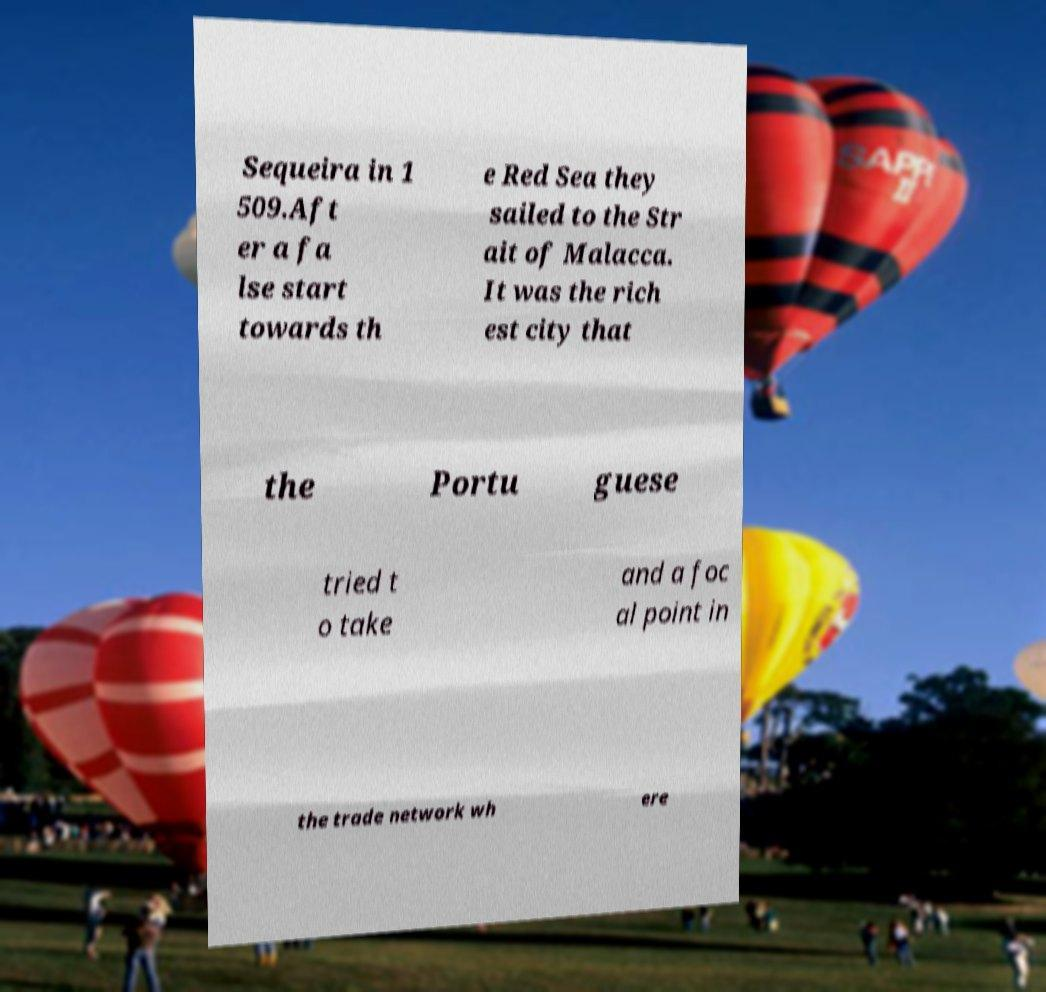For documentation purposes, I need the text within this image transcribed. Could you provide that? Sequeira in 1 509.Aft er a fa lse start towards th e Red Sea they sailed to the Str ait of Malacca. It was the rich est city that the Portu guese tried t o take and a foc al point in the trade network wh ere 